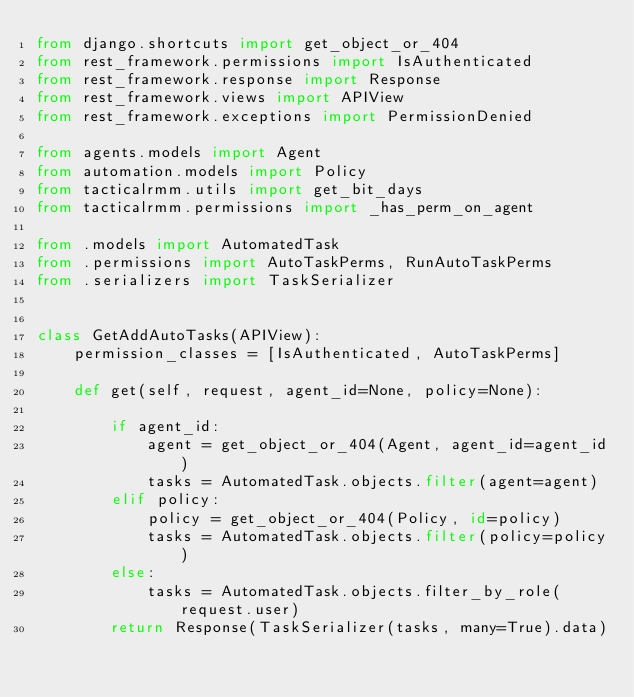Convert code to text. <code><loc_0><loc_0><loc_500><loc_500><_Python_>from django.shortcuts import get_object_or_404
from rest_framework.permissions import IsAuthenticated
from rest_framework.response import Response
from rest_framework.views import APIView
from rest_framework.exceptions import PermissionDenied

from agents.models import Agent
from automation.models import Policy
from tacticalrmm.utils import get_bit_days
from tacticalrmm.permissions import _has_perm_on_agent

from .models import AutomatedTask
from .permissions import AutoTaskPerms, RunAutoTaskPerms
from .serializers import TaskSerializer


class GetAddAutoTasks(APIView):
    permission_classes = [IsAuthenticated, AutoTaskPerms]

    def get(self, request, agent_id=None, policy=None):

        if agent_id:
            agent = get_object_or_404(Agent, agent_id=agent_id)
            tasks = AutomatedTask.objects.filter(agent=agent)
        elif policy:
            policy = get_object_or_404(Policy, id=policy)
            tasks = AutomatedTask.objects.filter(policy=policy)
        else:
            tasks = AutomatedTask.objects.filter_by_role(request.user)
        return Response(TaskSerializer(tasks, many=True).data)
</code> 